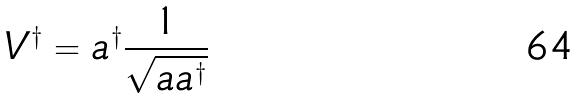<formula> <loc_0><loc_0><loc_500><loc_500>V ^ { \dagger } = a ^ { \dagger } \frac { 1 } { \sqrt { a a ^ { \dagger } } }</formula> 